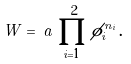<formula> <loc_0><loc_0><loc_500><loc_500>W = \, a \, \prod _ { i = 1 } ^ { 2 } \phi _ { i } ^ { n _ { i } } \, .</formula> 